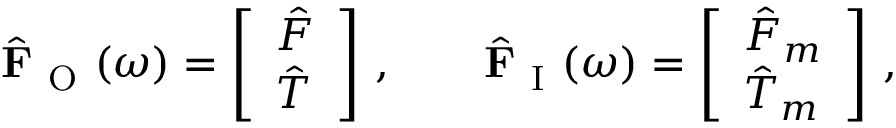<formula> <loc_0><loc_0><loc_500><loc_500>\hat { F } _ { O } ( \omega ) = \left [ \begin{array} { l } { \hat { F } } \\ { \hat { T } } \end{array} \right ] \, , \quad \hat { F } _ { I } ( \omega ) = \left [ \begin{array} { l } { \hat { F } _ { m } } \\ { \hat { T } _ { m } } \end{array} \right ] \, ,</formula> 